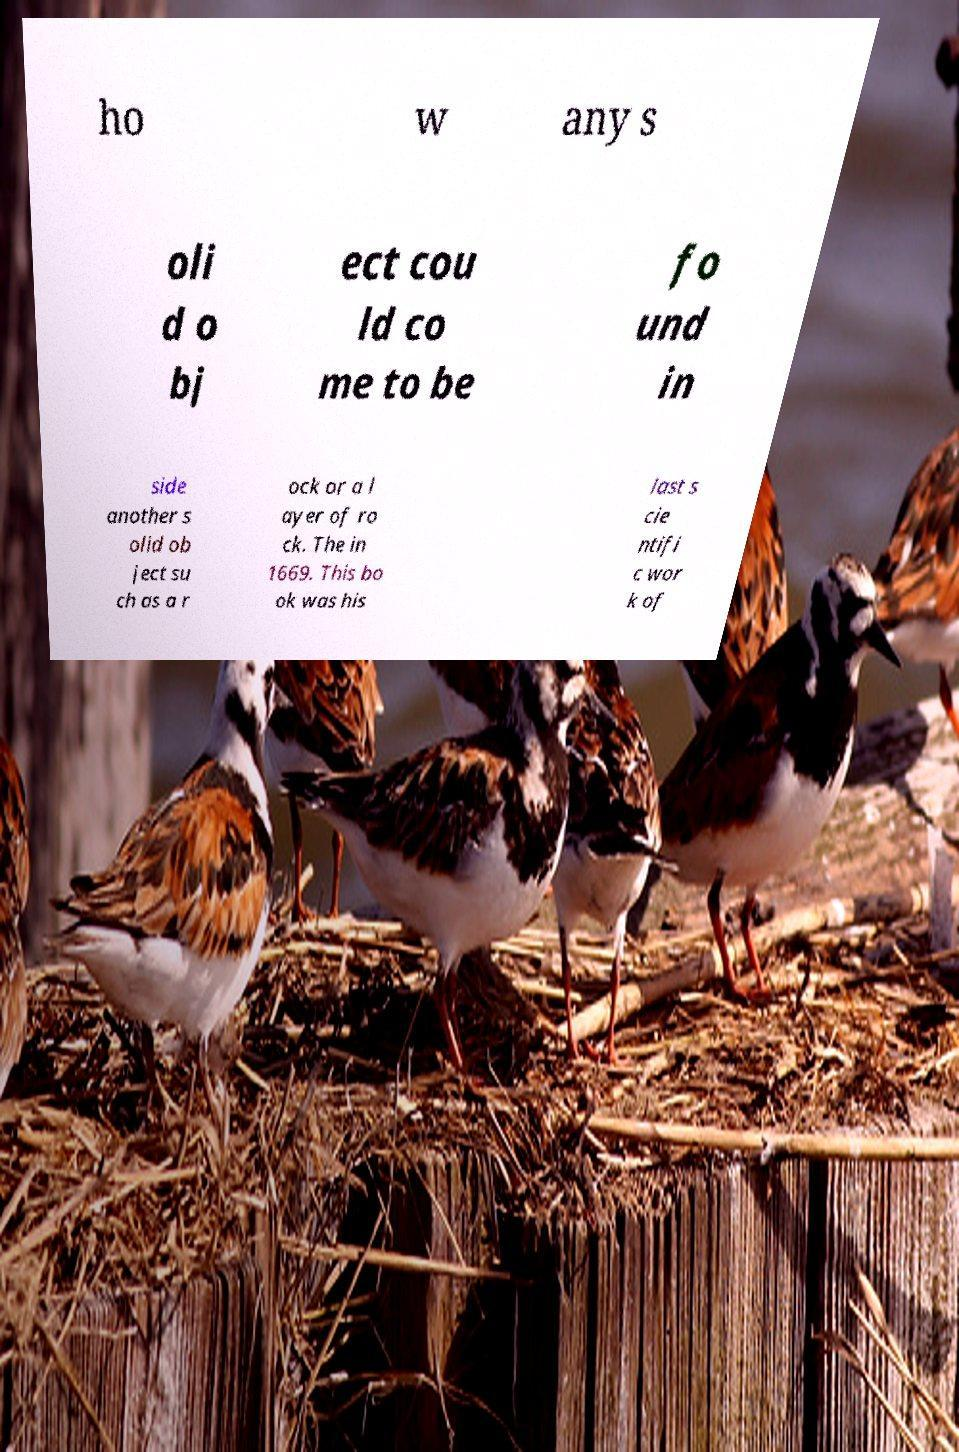Could you extract and type out the text from this image? ho w any s oli d o bj ect cou ld co me to be fo und in side another s olid ob ject su ch as a r ock or a l ayer of ro ck. The in 1669. This bo ok was his last s cie ntifi c wor k of 